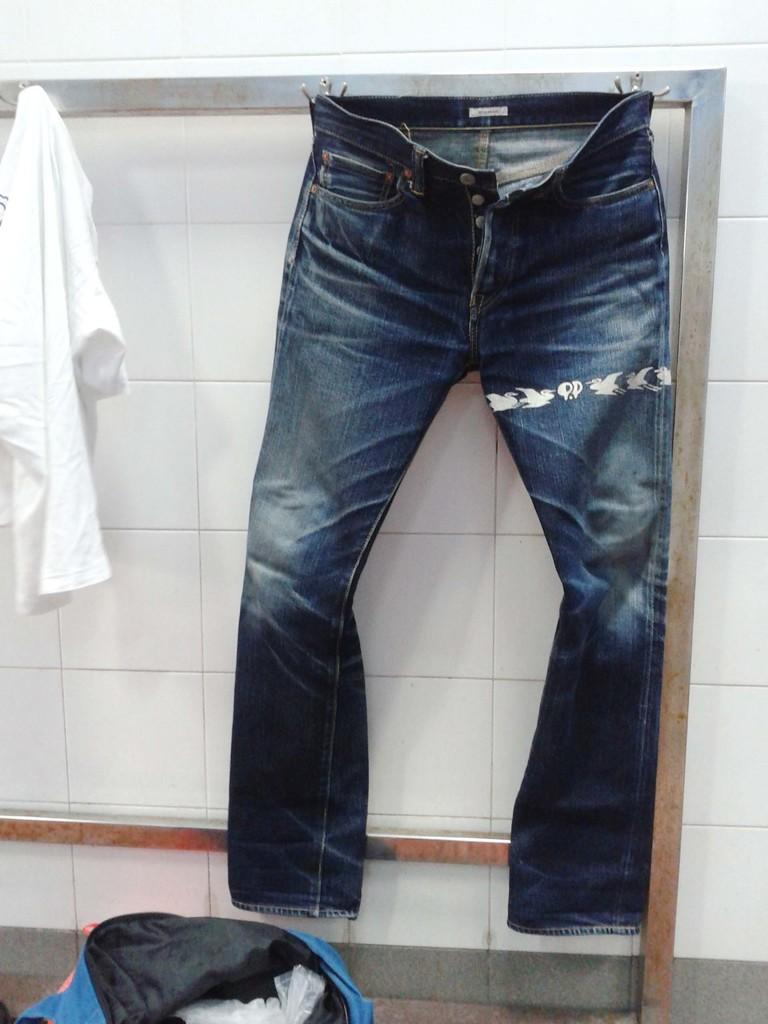What type of clothing is on a hanger in the image? There are jeans on a hanger in the image. What other piece of clothing is hanging in the image? There is a t-shirt hanging on the side in the image. What type of accessory is present in the image? There is a bag in the image. Where can the rail be seen in the image? There is no rail present in the image. How is the honey being used in the image? There is no honey present in the image. 